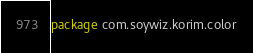<code> <loc_0><loc_0><loc_500><loc_500><_Kotlin_>package com.soywiz.korim.color
</code> 